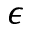Convert formula to latex. <formula><loc_0><loc_0><loc_500><loc_500>\epsilon</formula> 